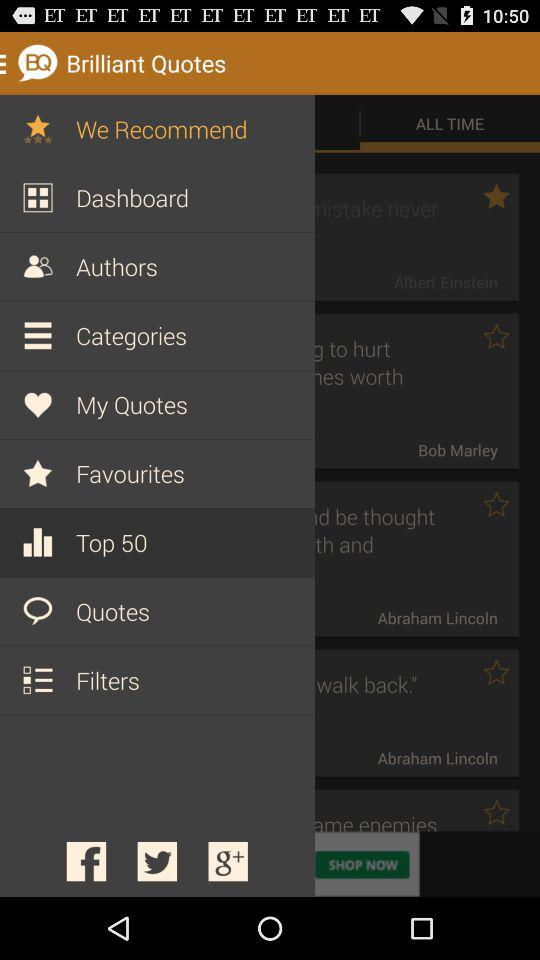What is the application name? the application name is "Brilliant Quotes". 